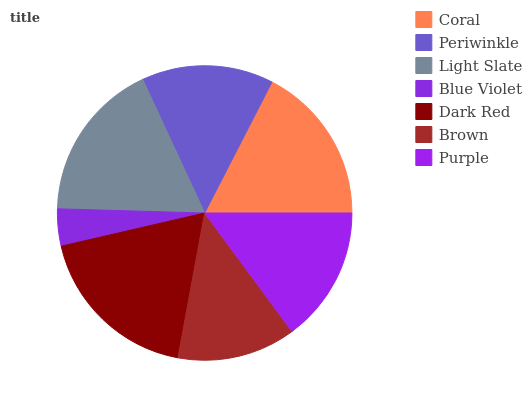Is Blue Violet the minimum?
Answer yes or no. Yes. Is Dark Red the maximum?
Answer yes or no. Yes. Is Periwinkle the minimum?
Answer yes or no. No. Is Periwinkle the maximum?
Answer yes or no. No. Is Coral greater than Periwinkle?
Answer yes or no. Yes. Is Periwinkle less than Coral?
Answer yes or no. Yes. Is Periwinkle greater than Coral?
Answer yes or no. No. Is Coral less than Periwinkle?
Answer yes or no. No. Is Purple the high median?
Answer yes or no. Yes. Is Purple the low median?
Answer yes or no. Yes. Is Dark Red the high median?
Answer yes or no. No. Is Brown the low median?
Answer yes or no. No. 